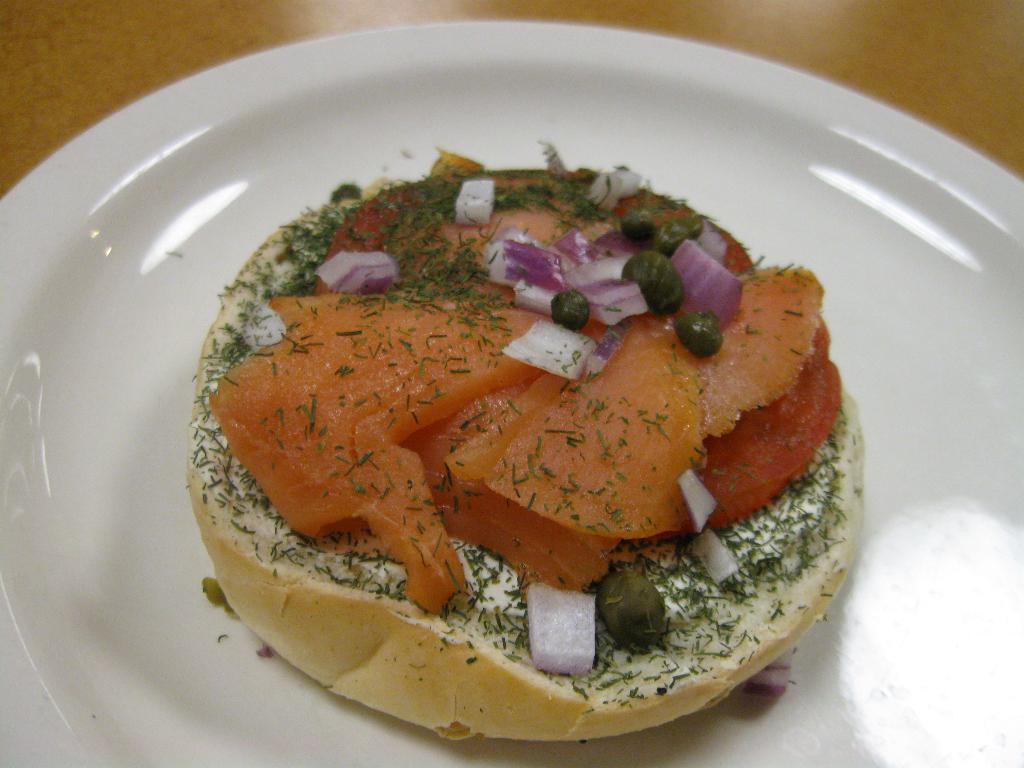What is on the white plate in the image? There is food on a white plate in the image. What can be seen in the background of the image? There is a table in the image. How many divisions are there in the straw in the image? There is no straw present in the image. 